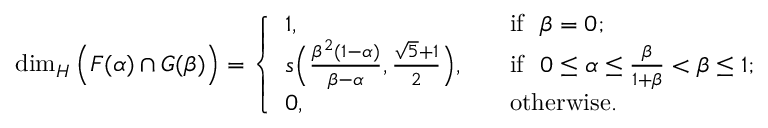Convert formula to latex. <formula><loc_0><loc_0><loc_500><loc_500>\dim _ { H } \left ( F ( \alpha ) \cap G ( \beta ) \right ) = \left \{ \begin{array} { l l } { 1 , } & { \quad i f \beta = 0 ; } \\ { s \left ( \frac { \beta ^ { 2 } ( 1 - \alpha ) } { \beta - \alpha } , { \frac { \sqrt { 5 } + 1 } { 2 } } \right ) , } & { \quad i f 0 \leq \alpha \leq \frac { \beta } { 1 + \beta } < \beta \leq 1 ; } \\ { 0 , } & { \quad o t h e r w i s e . } \end{array}</formula> 